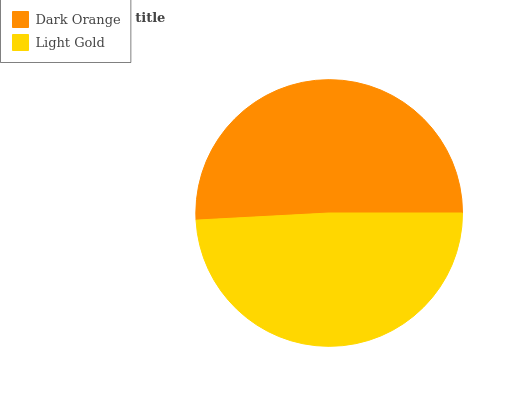Is Light Gold the minimum?
Answer yes or no. Yes. Is Dark Orange the maximum?
Answer yes or no. Yes. Is Light Gold the maximum?
Answer yes or no. No. Is Dark Orange greater than Light Gold?
Answer yes or no. Yes. Is Light Gold less than Dark Orange?
Answer yes or no. Yes. Is Light Gold greater than Dark Orange?
Answer yes or no. No. Is Dark Orange less than Light Gold?
Answer yes or no. No. Is Dark Orange the high median?
Answer yes or no. Yes. Is Light Gold the low median?
Answer yes or no. Yes. Is Light Gold the high median?
Answer yes or no. No. Is Dark Orange the low median?
Answer yes or no. No. 